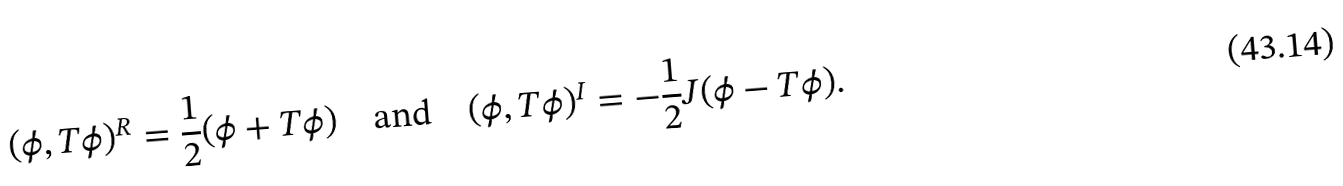Convert formula to latex. <formula><loc_0><loc_0><loc_500><loc_500>( \phi , T \phi ) ^ { R } = \frac { 1 } { 2 } ( \phi + T \phi ) \quad \text {and} \quad ( \phi , T \phi ) ^ { I } = - \frac { 1 } { 2 } J ( \phi - T \phi ) .</formula> 